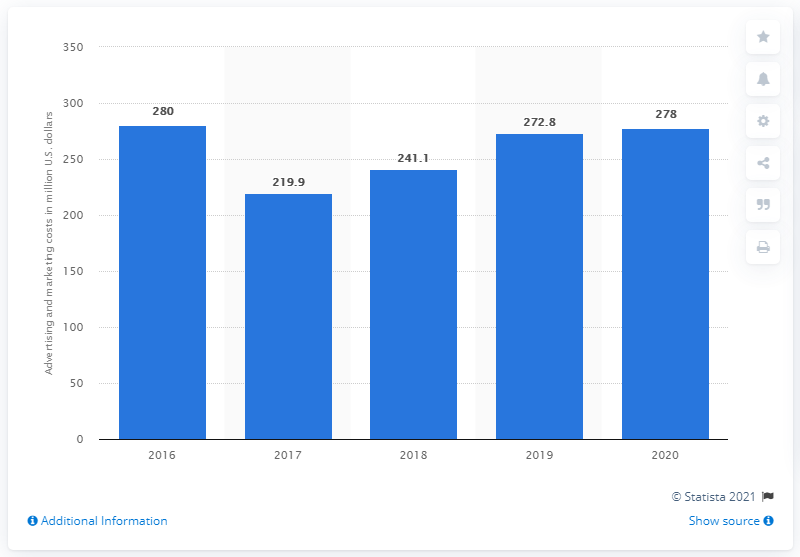Outline some significant characteristics in this image. Polo Ralph Lauren's advertising and marketing expenses in the United States during FY2020 were approximately $278 million. 